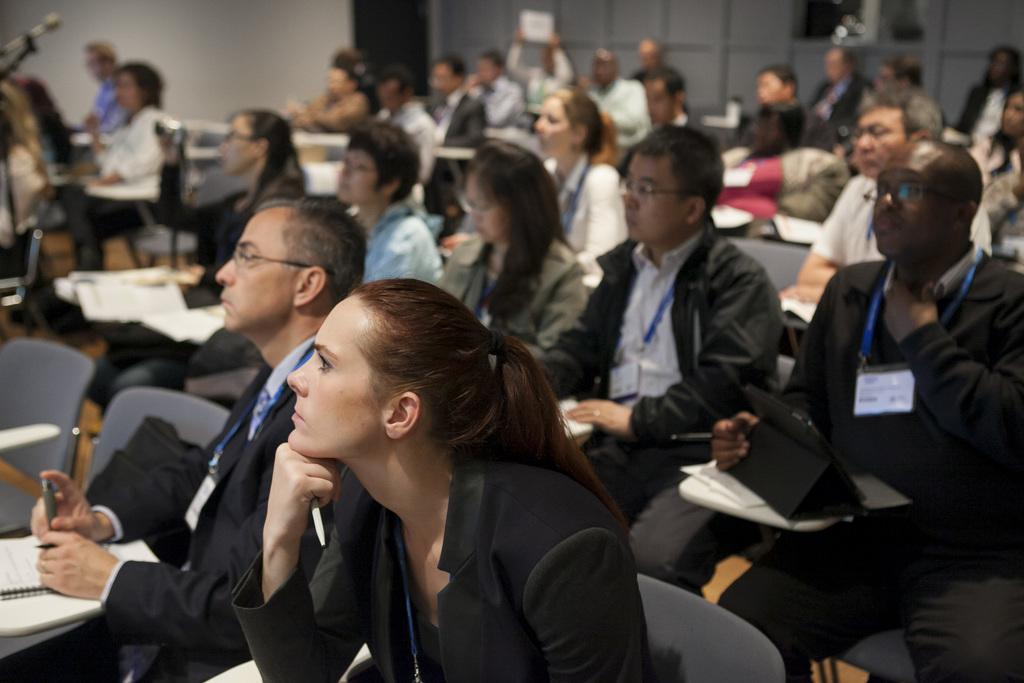How many people are in the image? There are many people in the image. What are the people doing in the image? The people are sitting on chairs. What objects are some people holding in the image? Some people are holding pens and some are holding books. What can be seen in the background of the image? There is a wall visible in the image. What type of straw is being used by the people in the image? There is no straw present in the image; the people are holding pens and books. 